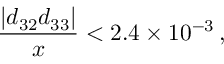<formula> <loc_0><loc_0><loc_500><loc_500>\frac { | d _ { 3 2 } d _ { 3 3 } | } { x } < 2 . 4 \times 1 0 ^ { - 3 } \, ,</formula> 